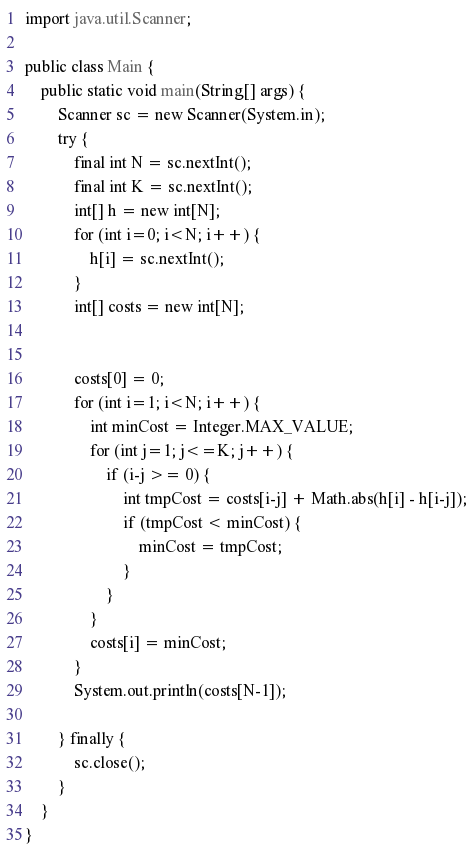Convert code to text. <code><loc_0><loc_0><loc_500><loc_500><_Java_>import java.util.Scanner;

public class Main {
    public static void main(String[] args) {
    	Scanner sc = new Scanner(System.in);
    	try {
    		final int N = sc.nextInt();
    		final int K = sc.nextInt();
    		int[] h = new int[N];
    		for (int i=0; i<N; i++) {
    			h[i] = sc.nextInt();
    		}
    		int[] costs = new int[N];


    		costs[0] = 0;
    		for (int i=1; i<N; i++) {
    			int minCost = Integer.MAX_VALUE;
    			for (int j=1; j<=K; j++) {
    				if (i-j >= 0) {
        				int tmpCost = costs[i-j] + Math.abs(h[i] - h[i-j]);
        				if (tmpCost < minCost) {
        					minCost = tmpCost;
        				}
    				}
    			}
    			costs[i] = minCost;
    		}
    		System.out.println(costs[N-1]);

    	} finally {
    		sc.close();
    	}
    }
}

</code> 